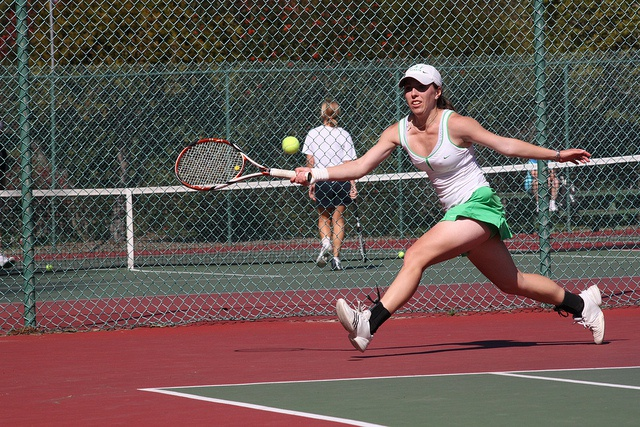Describe the objects in this image and their specific colors. I can see people in black, lightpink, lavender, and maroon tones, people in black, lavender, gray, and lightpink tones, tennis racket in black, gray, darkgray, and lightgray tones, people in black, gray, darkgray, and teal tones, and sports ball in black, khaki, and olive tones in this image. 